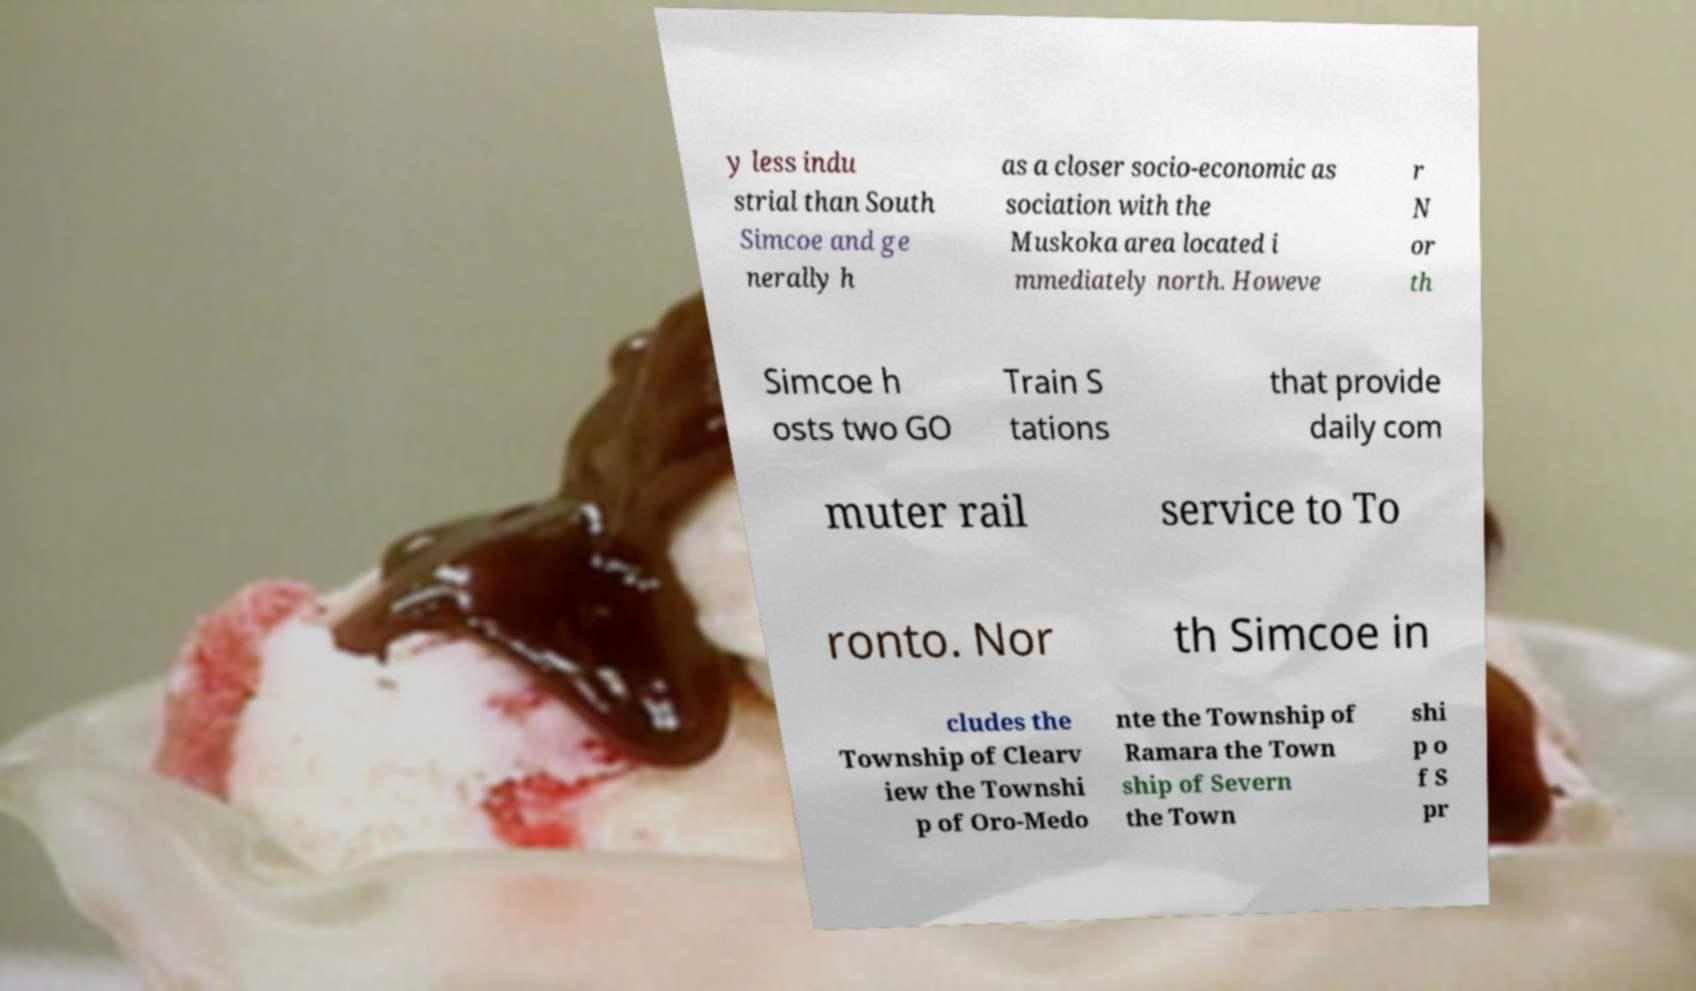Could you assist in decoding the text presented in this image and type it out clearly? y less indu strial than South Simcoe and ge nerally h as a closer socio-economic as sociation with the Muskoka area located i mmediately north. Howeve r N or th Simcoe h osts two GO Train S tations that provide daily com muter rail service to To ronto. Nor th Simcoe in cludes the Township of Clearv iew the Townshi p of Oro-Medo nte the Township of Ramara the Town ship of Severn the Town shi p o f S pr 